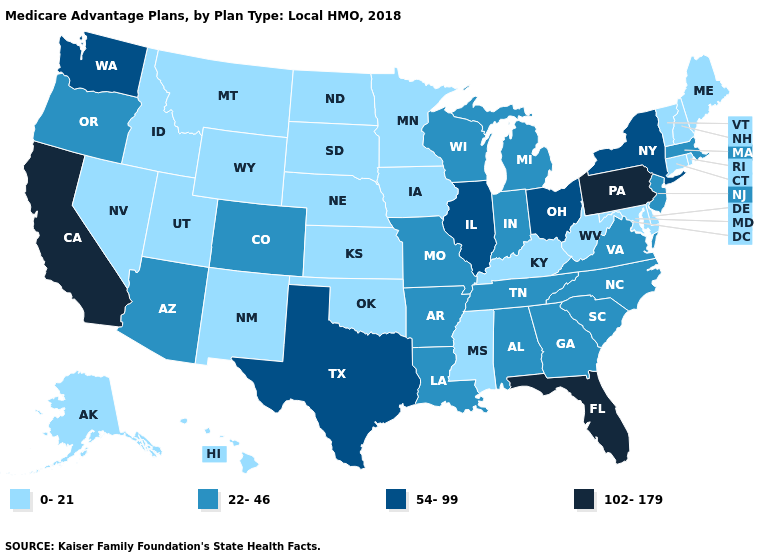Does the map have missing data?
Be succinct. No. Which states have the highest value in the USA?
Answer briefly. California, Florida, Pennsylvania. What is the lowest value in the South?
Answer briefly. 0-21. Among the states that border Vermont , which have the highest value?
Concise answer only. New York. What is the value of Montana?
Keep it brief. 0-21. What is the lowest value in the MidWest?
Write a very short answer. 0-21. Name the states that have a value in the range 0-21?
Keep it brief. Alaska, Connecticut, Delaware, Hawaii, Iowa, Idaho, Kansas, Kentucky, Maryland, Maine, Minnesota, Mississippi, Montana, North Dakota, Nebraska, New Hampshire, New Mexico, Nevada, Oklahoma, Rhode Island, South Dakota, Utah, Vermont, West Virginia, Wyoming. Name the states that have a value in the range 0-21?
Concise answer only. Alaska, Connecticut, Delaware, Hawaii, Iowa, Idaho, Kansas, Kentucky, Maryland, Maine, Minnesota, Mississippi, Montana, North Dakota, Nebraska, New Hampshire, New Mexico, Nevada, Oklahoma, Rhode Island, South Dakota, Utah, Vermont, West Virginia, Wyoming. Does Alaska have a lower value than Virginia?
Concise answer only. Yes. What is the value of Texas?
Answer briefly. 54-99. Name the states that have a value in the range 54-99?
Keep it brief. Illinois, New York, Ohio, Texas, Washington. Which states hav the highest value in the MidWest?
Quick response, please. Illinois, Ohio. Among the states that border Arkansas , does Mississippi have the lowest value?
Give a very brief answer. Yes. What is the value of Kansas?
Keep it brief. 0-21. How many symbols are there in the legend?
Quick response, please. 4. 